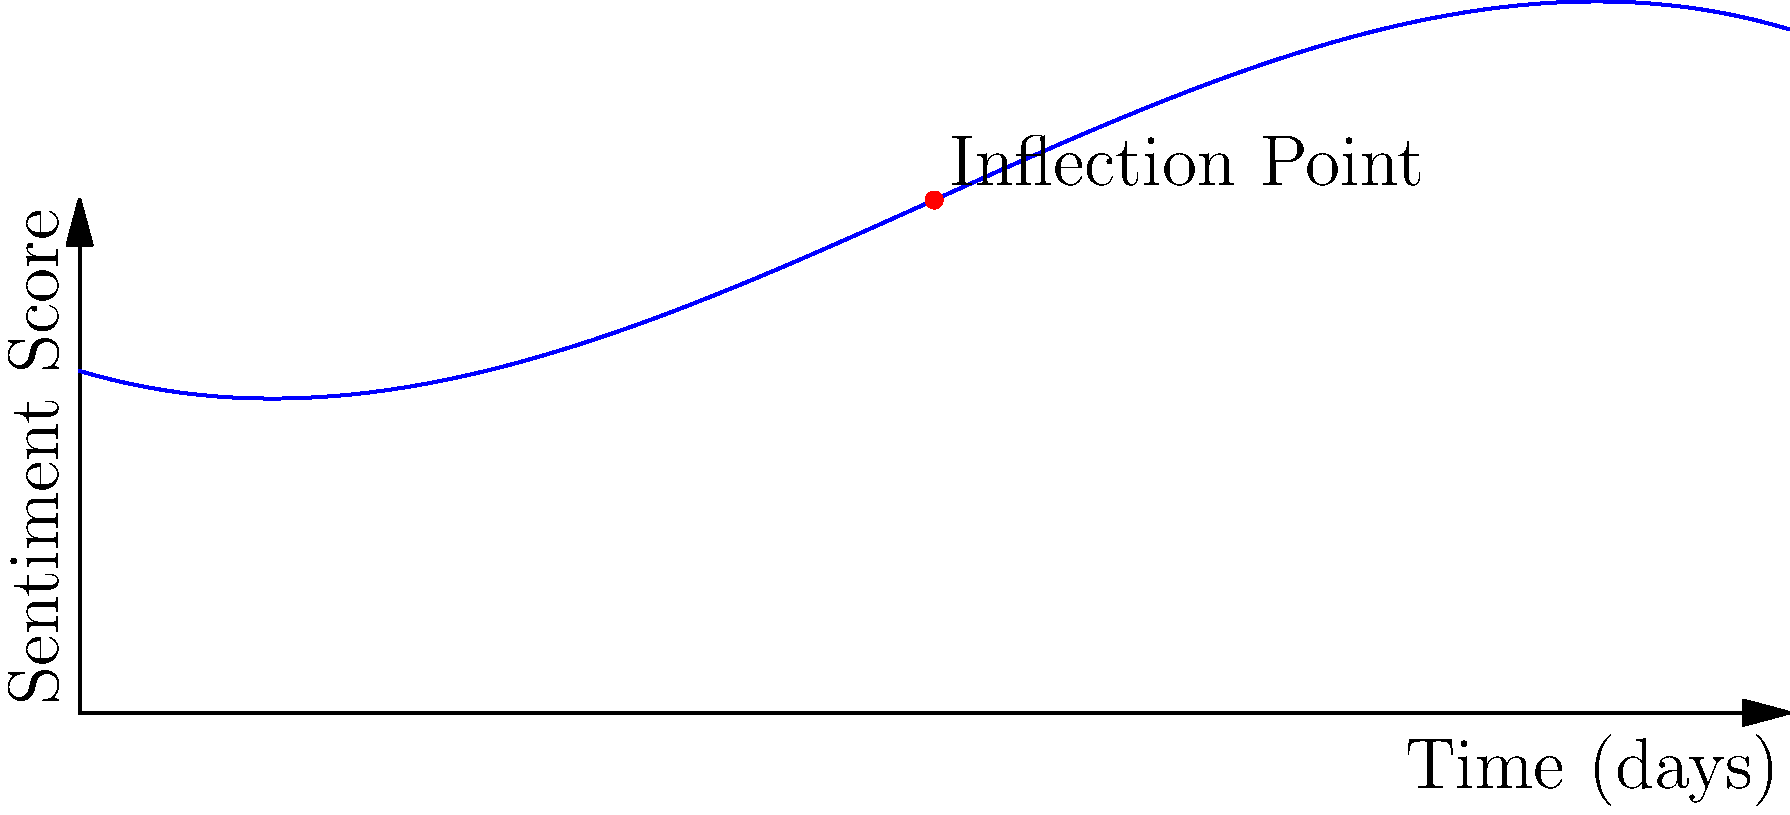Given the curve representing sentiment analysis of user comments over time, find the inflection point(s) of the function $f(x) = -0.01x^3 + 0.15x^2 - 0.3x + 2$, where $x$ represents time in days and $f(x)$ represents the sentiment score. To find the inflection point(s), we need to follow these steps:

1) The inflection point occurs where the second derivative of the function changes sign, or equivalently, where the second derivative equals zero.

2) First, let's find the first derivative:
   $f'(x) = -0.03x^2 + 0.3x - 0.3$

3) Now, let's find the second derivative:
   $f''(x) = -0.06x + 0.3$

4) Set the second derivative equal to zero and solve for x:
   $-0.06x + 0.3 = 0$
   $-0.06x = -0.3$
   $x = 5$

5) To confirm this is an inflection point, we can check that the second derivative changes sign at $x = 5$:
   For $x < 5$, $f''(x) > 0$
   For $x > 5$, $f''(x) < 0$

6) Therefore, the inflection point occurs at $x = 5$.

7) To find the y-coordinate, we plug $x = 5$ into the original function:
   $f(5) = -0.01(5^3) + 0.15(5^2) - 0.3(5) + 2 = 2.5$

Thus, the inflection point is at (5, 2.5).
Answer: (5, 2.5) 